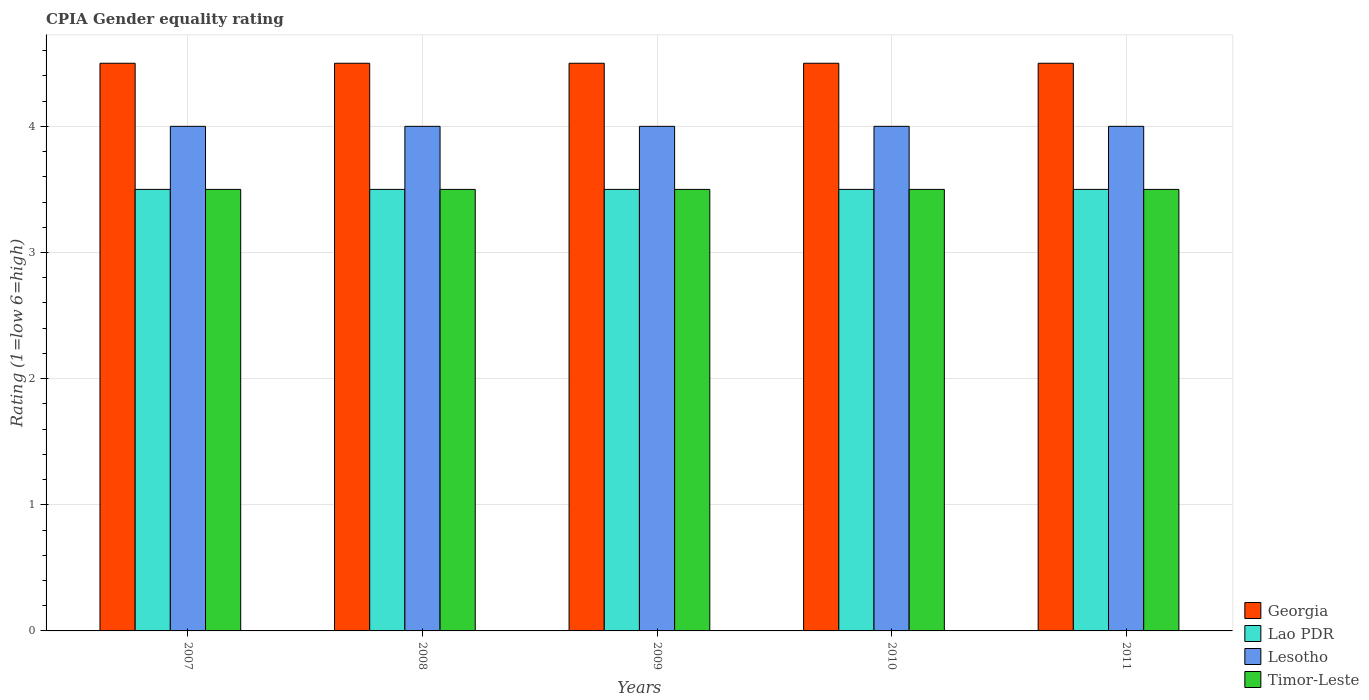Are the number of bars per tick equal to the number of legend labels?
Your answer should be very brief. Yes. How many bars are there on the 3rd tick from the left?
Make the answer very short. 4. What is the CPIA rating in Lao PDR in 2010?
Provide a succinct answer. 3.5. Across all years, what is the minimum CPIA rating in Georgia?
Offer a very short reply. 4.5. In which year was the CPIA rating in Lesotho maximum?
Offer a terse response. 2007. What is the total CPIA rating in Lesotho in the graph?
Give a very brief answer. 20. What is the difference between the CPIA rating in Georgia in 2011 and the CPIA rating in Lao PDR in 2008?
Provide a short and direct response. 1. What is the average CPIA rating in Timor-Leste per year?
Your answer should be very brief. 3.5. In the year 2011, what is the difference between the CPIA rating in Timor-Leste and CPIA rating in Lao PDR?
Your answer should be very brief. 0. What is the ratio of the CPIA rating in Timor-Leste in 2007 to that in 2011?
Your answer should be very brief. 1. Is the difference between the CPIA rating in Timor-Leste in 2007 and 2010 greater than the difference between the CPIA rating in Lao PDR in 2007 and 2010?
Offer a very short reply. No. What is the difference between the highest and the second highest CPIA rating in Lao PDR?
Your answer should be very brief. 0. What is the difference between the highest and the lowest CPIA rating in Lesotho?
Provide a short and direct response. 0. Is it the case that in every year, the sum of the CPIA rating in Lesotho and CPIA rating in Lao PDR is greater than the sum of CPIA rating in Georgia and CPIA rating in Timor-Leste?
Give a very brief answer. Yes. What does the 4th bar from the left in 2010 represents?
Give a very brief answer. Timor-Leste. What does the 4th bar from the right in 2010 represents?
Your answer should be very brief. Georgia. Is it the case that in every year, the sum of the CPIA rating in Lesotho and CPIA rating in Timor-Leste is greater than the CPIA rating in Lao PDR?
Ensure brevity in your answer.  Yes. Are all the bars in the graph horizontal?
Provide a short and direct response. No. How many years are there in the graph?
Provide a short and direct response. 5. What is the difference between two consecutive major ticks on the Y-axis?
Provide a succinct answer. 1. Are the values on the major ticks of Y-axis written in scientific E-notation?
Offer a terse response. No. Does the graph contain any zero values?
Give a very brief answer. No. Does the graph contain grids?
Keep it short and to the point. Yes. How are the legend labels stacked?
Ensure brevity in your answer.  Vertical. What is the title of the graph?
Give a very brief answer. CPIA Gender equality rating. What is the label or title of the X-axis?
Your answer should be very brief. Years. What is the label or title of the Y-axis?
Your response must be concise. Rating (1=low 6=high). What is the Rating (1=low 6=high) in Georgia in 2007?
Provide a succinct answer. 4.5. What is the Rating (1=low 6=high) in Timor-Leste in 2007?
Your response must be concise. 3.5. What is the Rating (1=low 6=high) of Georgia in 2008?
Provide a succinct answer. 4.5. What is the Rating (1=low 6=high) in Lao PDR in 2008?
Make the answer very short. 3.5. What is the Rating (1=low 6=high) in Timor-Leste in 2008?
Your response must be concise. 3.5. What is the Rating (1=low 6=high) of Georgia in 2009?
Your answer should be very brief. 4.5. What is the Rating (1=low 6=high) of Lesotho in 2009?
Your answer should be very brief. 4. What is the Rating (1=low 6=high) in Georgia in 2010?
Offer a very short reply. 4.5. What is the Rating (1=low 6=high) in Lao PDR in 2010?
Your answer should be very brief. 3.5. What is the Rating (1=low 6=high) in Georgia in 2011?
Ensure brevity in your answer.  4.5. What is the Rating (1=low 6=high) of Lesotho in 2011?
Keep it short and to the point. 4. Across all years, what is the maximum Rating (1=low 6=high) of Georgia?
Your answer should be very brief. 4.5. Across all years, what is the maximum Rating (1=low 6=high) of Lao PDR?
Provide a succinct answer. 3.5. Across all years, what is the maximum Rating (1=low 6=high) in Lesotho?
Ensure brevity in your answer.  4. Across all years, what is the maximum Rating (1=low 6=high) in Timor-Leste?
Give a very brief answer. 3.5. Across all years, what is the minimum Rating (1=low 6=high) of Georgia?
Offer a very short reply. 4.5. Across all years, what is the minimum Rating (1=low 6=high) in Lao PDR?
Make the answer very short. 3.5. Across all years, what is the minimum Rating (1=low 6=high) of Lesotho?
Keep it short and to the point. 4. Across all years, what is the minimum Rating (1=low 6=high) of Timor-Leste?
Give a very brief answer. 3.5. What is the total Rating (1=low 6=high) of Lesotho in the graph?
Ensure brevity in your answer.  20. What is the total Rating (1=low 6=high) of Timor-Leste in the graph?
Your answer should be compact. 17.5. What is the difference between the Rating (1=low 6=high) in Lao PDR in 2007 and that in 2008?
Keep it short and to the point. 0. What is the difference between the Rating (1=low 6=high) in Georgia in 2007 and that in 2009?
Ensure brevity in your answer.  0. What is the difference between the Rating (1=low 6=high) of Lao PDR in 2007 and that in 2009?
Your answer should be compact. 0. What is the difference between the Rating (1=low 6=high) of Lesotho in 2007 and that in 2009?
Your answer should be very brief. 0. What is the difference between the Rating (1=low 6=high) of Timor-Leste in 2007 and that in 2009?
Give a very brief answer. 0. What is the difference between the Rating (1=low 6=high) of Georgia in 2007 and that in 2010?
Your response must be concise. 0. What is the difference between the Rating (1=low 6=high) of Lesotho in 2007 and that in 2010?
Offer a very short reply. 0. What is the difference between the Rating (1=low 6=high) of Timor-Leste in 2007 and that in 2010?
Your answer should be very brief. 0. What is the difference between the Rating (1=low 6=high) in Georgia in 2007 and that in 2011?
Keep it short and to the point. 0. What is the difference between the Rating (1=low 6=high) of Lesotho in 2007 and that in 2011?
Your response must be concise. 0. What is the difference between the Rating (1=low 6=high) in Timor-Leste in 2007 and that in 2011?
Offer a terse response. 0. What is the difference between the Rating (1=low 6=high) of Georgia in 2008 and that in 2009?
Ensure brevity in your answer.  0. What is the difference between the Rating (1=low 6=high) of Lao PDR in 2008 and that in 2009?
Give a very brief answer. 0. What is the difference between the Rating (1=low 6=high) of Lesotho in 2008 and that in 2009?
Provide a short and direct response. 0. What is the difference between the Rating (1=low 6=high) of Timor-Leste in 2008 and that in 2009?
Make the answer very short. 0. What is the difference between the Rating (1=low 6=high) in Georgia in 2008 and that in 2010?
Your response must be concise. 0. What is the difference between the Rating (1=low 6=high) in Lao PDR in 2008 and that in 2010?
Offer a terse response. 0. What is the difference between the Rating (1=low 6=high) of Timor-Leste in 2008 and that in 2010?
Provide a short and direct response. 0. What is the difference between the Rating (1=low 6=high) of Lao PDR in 2008 and that in 2011?
Your answer should be very brief. 0. What is the difference between the Rating (1=low 6=high) in Timor-Leste in 2008 and that in 2011?
Give a very brief answer. 0. What is the difference between the Rating (1=low 6=high) of Georgia in 2009 and that in 2010?
Make the answer very short. 0. What is the difference between the Rating (1=low 6=high) in Lesotho in 2009 and that in 2010?
Your answer should be compact. 0. What is the difference between the Rating (1=low 6=high) of Lesotho in 2009 and that in 2011?
Provide a succinct answer. 0. What is the difference between the Rating (1=low 6=high) in Georgia in 2007 and the Rating (1=low 6=high) in Lao PDR in 2008?
Provide a succinct answer. 1. What is the difference between the Rating (1=low 6=high) in Georgia in 2007 and the Rating (1=low 6=high) in Timor-Leste in 2008?
Make the answer very short. 1. What is the difference between the Rating (1=low 6=high) of Lao PDR in 2007 and the Rating (1=low 6=high) of Lesotho in 2008?
Provide a short and direct response. -0.5. What is the difference between the Rating (1=low 6=high) in Lao PDR in 2007 and the Rating (1=low 6=high) in Timor-Leste in 2008?
Ensure brevity in your answer.  0. What is the difference between the Rating (1=low 6=high) of Georgia in 2007 and the Rating (1=low 6=high) of Lao PDR in 2009?
Keep it short and to the point. 1. What is the difference between the Rating (1=low 6=high) of Georgia in 2007 and the Rating (1=low 6=high) of Lesotho in 2009?
Your answer should be very brief. 0.5. What is the difference between the Rating (1=low 6=high) of Georgia in 2007 and the Rating (1=low 6=high) of Timor-Leste in 2009?
Your answer should be compact. 1. What is the difference between the Rating (1=low 6=high) of Lao PDR in 2007 and the Rating (1=low 6=high) of Lesotho in 2009?
Provide a short and direct response. -0.5. What is the difference between the Rating (1=low 6=high) of Georgia in 2007 and the Rating (1=low 6=high) of Lao PDR in 2010?
Keep it short and to the point. 1. What is the difference between the Rating (1=low 6=high) in Georgia in 2007 and the Rating (1=low 6=high) in Lesotho in 2010?
Provide a short and direct response. 0.5. What is the difference between the Rating (1=low 6=high) of Lao PDR in 2007 and the Rating (1=low 6=high) of Lesotho in 2010?
Provide a short and direct response. -0.5. What is the difference between the Rating (1=low 6=high) in Lao PDR in 2007 and the Rating (1=low 6=high) in Timor-Leste in 2010?
Keep it short and to the point. 0. What is the difference between the Rating (1=low 6=high) in Lesotho in 2007 and the Rating (1=low 6=high) in Timor-Leste in 2010?
Ensure brevity in your answer.  0.5. What is the difference between the Rating (1=low 6=high) in Georgia in 2007 and the Rating (1=low 6=high) in Lao PDR in 2011?
Your answer should be very brief. 1. What is the difference between the Rating (1=low 6=high) of Georgia in 2007 and the Rating (1=low 6=high) of Lesotho in 2011?
Your answer should be compact. 0.5. What is the difference between the Rating (1=low 6=high) in Georgia in 2007 and the Rating (1=low 6=high) in Timor-Leste in 2011?
Provide a short and direct response. 1. What is the difference between the Rating (1=low 6=high) of Lao PDR in 2007 and the Rating (1=low 6=high) of Lesotho in 2011?
Make the answer very short. -0.5. What is the difference between the Rating (1=low 6=high) of Lao PDR in 2007 and the Rating (1=low 6=high) of Timor-Leste in 2011?
Make the answer very short. 0. What is the difference between the Rating (1=low 6=high) of Georgia in 2008 and the Rating (1=low 6=high) of Lao PDR in 2009?
Offer a terse response. 1. What is the difference between the Rating (1=low 6=high) of Georgia in 2008 and the Rating (1=low 6=high) of Timor-Leste in 2009?
Offer a very short reply. 1. What is the difference between the Rating (1=low 6=high) in Lesotho in 2008 and the Rating (1=low 6=high) in Timor-Leste in 2009?
Provide a succinct answer. 0.5. What is the difference between the Rating (1=low 6=high) in Georgia in 2008 and the Rating (1=low 6=high) in Timor-Leste in 2010?
Offer a terse response. 1. What is the difference between the Rating (1=low 6=high) of Lao PDR in 2008 and the Rating (1=low 6=high) of Lesotho in 2010?
Your answer should be compact. -0.5. What is the difference between the Rating (1=low 6=high) of Lesotho in 2008 and the Rating (1=low 6=high) of Timor-Leste in 2010?
Your answer should be compact. 0.5. What is the difference between the Rating (1=low 6=high) of Georgia in 2008 and the Rating (1=low 6=high) of Lao PDR in 2011?
Make the answer very short. 1. What is the difference between the Rating (1=low 6=high) in Georgia in 2008 and the Rating (1=low 6=high) in Timor-Leste in 2011?
Your answer should be very brief. 1. What is the difference between the Rating (1=low 6=high) of Lesotho in 2008 and the Rating (1=low 6=high) of Timor-Leste in 2011?
Keep it short and to the point. 0.5. What is the difference between the Rating (1=low 6=high) of Georgia in 2009 and the Rating (1=low 6=high) of Lesotho in 2010?
Offer a terse response. 0.5. What is the difference between the Rating (1=low 6=high) of Georgia in 2009 and the Rating (1=low 6=high) of Timor-Leste in 2010?
Ensure brevity in your answer.  1. What is the difference between the Rating (1=low 6=high) of Lao PDR in 2009 and the Rating (1=low 6=high) of Lesotho in 2010?
Make the answer very short. -0.5. What is the difference between the Rating (1=low 6=high) in Lesotho in 2009 and the Rating (1=low 6=high) in Timor-Leste in 2010?
Your answer should be compact. 0.5. What is the difference between the Rating (1=low 6=high) in Georgia in 2009 and the Rating (1=low 6=high) in Lao PDR in 2011?
Your answer should be compact. 1. What is the difference between the Rating (1=low 6=high) of Georgia in 2009 and the Rating (1=low 6=high) of Timor-Leste in 2011?
Keep it short and to the point. 1. What is the difference between the Rating (1=low 6=high) of Georgia in 2010 and the Rating (1=low 6=high) of Lao PDR in 2011?
Provide a succinct answer. 1. What is the difference between the Rating (1=low 6=high) of Georgia in 2010 and the Rating (1=low 6=high) of Lesotho in 2011?
Your answer should be compact. 0.5. What is the difference between the Rating (1=low 6=high) in Lao PDR in 2010 and the Rating (1=low 6=high) in Lesotho in 2011?
Offer a very short reply. -0.5. What is the difference between the Rating (1=low 6=high) in Lesotho in 2010 and the Rating (1=low 6=high) in Timor-Leste in 2011?
Your response must be concise. 0.5. What is the average Rating (1=low 6=high) in Georgia per year?
Keep it short and to the point. 4.5. What is the average Rating (1=low 6=high) in Lesotho per year?
Provide a short and direct response. 4. In the year 2007, what is the difference between the Rating (1=low 6=high) in Georgia and Rating (1=low 6=high) in Lao PDR?
Offer a terse response. 1. In the year 2007, what is the difference between the Rating (1=low 6=high) of Georgia and Rating (1=low 6=high) of Lesotho?
Give a very brief answer. 0.5. In the year 2007, what is the difference between the Rating (1=low 6=high) of Georgia and Rating (1=low 6=high) of Timor-Leste?
Keep it short and to the point. 1. In the year 2007, what is the difference between the Rating (1=low 6=high) in Lao PDR and Rating (1=low 6=high) in Lesotho?
Provide a succinct answer. -0.5. In the year 2007, what is the difference between the Rating (1=low 6=high) of Lao PDR and Rating (1=low 6=high) of Timor-Leste?
Make the answer very short. 0. In the year 2007, what is the difference between the Rating (1=low 6=high) of Lesotho and Rating (1=low 6=high) of Timor-Leste?
Keep it short and to the point. 0.5. In the year 2008, what is the difference between the Rating (1=low 6=high) in Lao PDR and Rating (1=low 6=high) in Lesotho?
Your answer should be very brief. -0.5. In the year 2008, what is the difference between the Rating (1=low 6=high) in Lao PDR and Rating (1=low 6=high) in Timor-Leste?
Ensure brevity in your answer.  0. In the year 2009, what is the difference between the Rating (1=low 6=high) of Georgia and Rating (1=low 6=high) of Lesotho?
Your answer should be compact. 0.5. In the year 2009, what is the difference between the Rating (1=low 6=high) of Lao PDR and Rating (1=low 6=high) of Lesotho?
Your answer should be very brief. -0.5. In the year 2009, what is the difference between the Rating (1=low 6=high) in Lao PDR and Rating (1=low 6=high) in Timor-Leste?
Give a very brief answer. 0. In the year 2010, what is the difference between the Rating (1=low 6=high) of Georgia and Rating (1=low 6=high) of Lao PDR?
Keep it short and to the point. 1. In the year 2010, what is the difference between the Rating (1=low 6=high) in Georgia and Rating (1=low 6=high) in Lesotho?
Ensure brevity in your answer.  0.5. In the year 2010, what is the difference between the Rating (1=low 6=high) in Georgia and Rating (1=low 6=high) in Timor-Leste?
Ensure brevity in your answer.  1. In the year 2010, what is the difference between the Rating (1=low 6=high) of Lao PDR and Rating (1=low 6=high) of Lesotho?
Offer a very short reply. -0.5. In the year 2011, what is the difference between the Rating (1=low 6=high) of Georgia and Rating (1=low 6=high) of Lao PDR?
Offer a very short reply. 1. In the year 2011, what is the difference between the Rating (1=low 6=high) in Georgia and Rating (1=low 6=high) in Timor-Leste?
Make the answer very short. 1. In the year 2011, what is the difference between the Rating (1=low 6=high) of Lao PDR and Rating (1=low 6=high) of Timor-Leste?
Offer a very short reply. 0. In the year 2011, what is the difference between the Rating (1=low 6=high) of Lesotho and Rating (1=low 6=high) of Timor-Leste?
Give a very brief answer. 0.5. What is the ratio of the Rating (1=low 6=high) in Georgia in 2007 to that in 2008?
Keep it short and to the point. 1. What is the ratio of the Rating (1=low 6=high) of Lao PDR in 2007 to that in 2008?
Provide a short and direct response. 1. What is the ratio of the Rating (1=low 6=high) of Timor-Leste in 2007 to that in 2008?
Offer a very short reply. 1. What is the ratio of the Rating (1=low 6=high) in Georgia in 2007 to that in 2009?
Your answer should be compact. 1. What is the ratio of the Rating (1=low 6=high) in Lao PDR in 2007 to that in 2009?
Make the answer very short. 1. What is the ratio of the Rating (1=low 6=high) of Timor-Leste in 2007 to that in 2009?
Provide a short and direct response. 1. What is the ratio of the Rating (1=low 6=high) in Georgia in 2007 to that in 2010?
Your answer should be compact. 1. What is the ratio of the Rating (1=low 6=high) of Lao PDR in 2007 to that in 2010?
Your answer should be compact. 1. What is the ratio of the Rating (1=low 6=high) in Lesotho in 2007 to that in 2010?
Your answer should be compact. 1. What is the ratio of the Rating (1=low 6=high) of Georgia in 2007 to that in 2011?
Your answer should be compact. 1. What is the ratio of the Rating (1=low 6=high) of Timor-Leste in 2007 to that in 2011?
Provide a succinct answer. 1. What is the ratio of the Rating (1=low 6=high) in Lesotho in 2008 to that in 2010?
Offer a very short reply. 1. What is the ratio of the Rating (1=low 6=high) of Timor-Leste in 2008 to that in 2010?
Offer a terse response. 1. What is the ratio of the Rating (1=low 6=high) of Lesotho in 2008 to that in 2011?
Keep it short and to the point. 1. What is the ratio of the Rating (1=low 6=high) in Timor-Leste in 2008 to that in 2011?
Keep it short and to the point. 1. What is the ratio of the Rating (1=low 6=high) in Georgia in 2009 to that in 2010?
Your answer should be very brief. 1. What is the ratio of the Rating (1=low 6=high) in Lao PDR in 2009 to that in 2010?
Provide a succinct answer. 1. What is the ratio of the Rating (1=low 6=high) in Lesotho in 2009 to that in 2010?
Provide a short and direct response. 1. What is the ratio of the Rating (1=low 6=high) in Georgia in 2009 to that in 2011?
Give a very brief answer. 1. What is the ratio of the Rating (1=low 6=high) of Timor-Leste in 2009 to that in 2011?
Your answer should be compact. 1. What is the ratio of the Rating (1=low 6=high) in Georgia in 2010 to that in 2011?
Ensure brevity in your answer.  1. What is the ratio of the Rating (1=low 6=high) in Lesotho in 2010 to that in 2011?
Keep it short and to the point. 1. What is the difference between the highest and the second highest Rating (1=low 6=high) in Lesotho?
Offer a very short reply. 0. What is the difference between the highest and the second highest Rating (1=low 6=high) of Timor-Leste?
Your response must be concise. 0. What is the difference between the highest and the lowest Rating (1=low 6=high) in Georgia?
Ensure brevity in your answer.  0. What is the difference between the highest and the lowest Rating (1=low 6=high) in Lesotho?
Your answer should be very brief. 0. What is the difference between the highest and the lowest Rating (1=low 6=high) of Timor-Leste?
Provide a short and direct response. 0. 